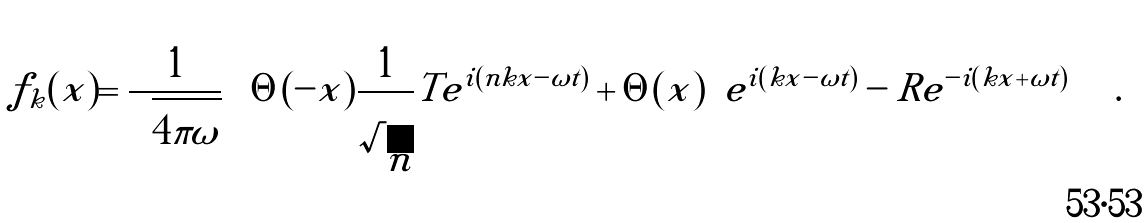Convert formula to latex. <formula><loc_0><loc_0><loc_500><loc_500>f _ { k } ( x ) = { \frac { 1 } { \sqrt { 4 \pi \omega } } } \left \{ \Theta ( - x ) { \frac { 1 } { \sqrt { n } } } T e ^ { i ( n k x - \omega t ) } + \Theta ( x ) \left [ e ^ { i ( k x - \omega t ) } - R e ^ { - i ( k x + \omega t ) } \right ] \right \} .</formula> 